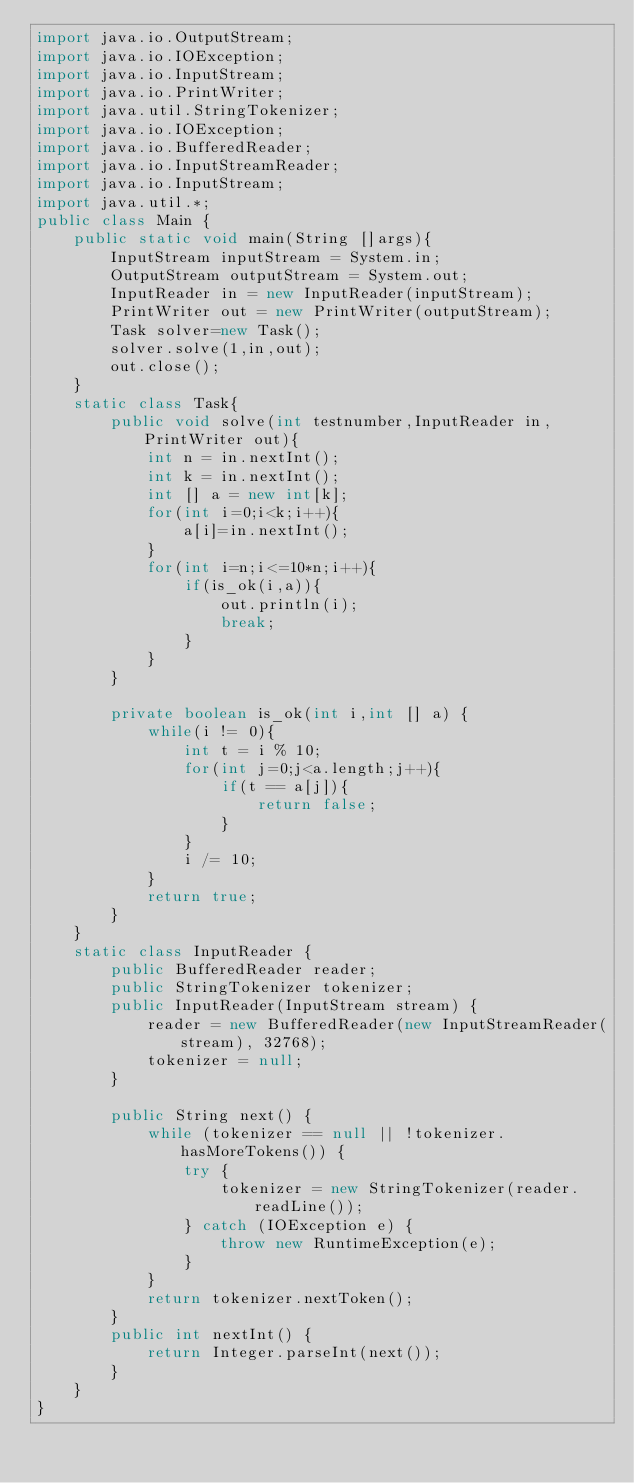<code> <loc_0><loc_0><loc_500><loc_500><_Java_>import java.io.OutputStream;
import java.io.IOException;
import java.io.InputStream;
import java.io.PrintWriter;
import java.util.StringTokenizer;
import java.io.IOException;
import java.io.BufferedReader;
import java.io.InputStreamReader;
import java.io.InputStream;
import java.util.*;
public class Main {
    public static void main(String []args){
        InputStream inputStream = System.in;
        OutputStream outputStream = System.out;
        InputReader in = new InputReader(inputStream);
        PrintWriter out = new PrintWriter(outputStream);
        Task solver=new Task();
        solver.solve(1,in,out);
        out.close();
    }
    static class Task{
        public void solve(int testnumber,InputReader in,PrintWriter out){
            int n = in.nextInt();
            int k = in.nextInt();
            int [] a = new int[k];
            for(int i=0;i<k;i++){
                a[i]=in.nextInt();
            }
            for(int i=n;i<=10*n;i++){
                if(is_ok(i,a)){
                    out.println(i);
                    break;
                }
            }
        }

        private boolean is_ok(int i,int [] a) {
            while(i != 0){
                int t = i % 10;
                for(int j=0;j<a.length;j++){
                    if(t == a[j]){
                        return false;
                    }
                }
                i /= 10;
            }
            return true;
        }
    }
    static class InputReader {
        public BufferedReader reader;
        public StringTokenizer tokenizer;
        public InputReader(InputStream stream) {
            reader = new BufferedReader(new InputStreamReader(stream), 32768);
            tokenizer = null;
        }

        public String next() {
            while (tokenizer == null || !tokenizer.hasMoreTokens()) {
                try {
                    tokenizer = new StringTokenizer(reader.readLine());
                } catch (IOException e) {
                    throw new RuntimeException(e);
                }
            }
            return tokenizer.nextToken();
        }
        public int nextInt() {
            return Integer.parseInt(next());
        }
    }
}
</code> 